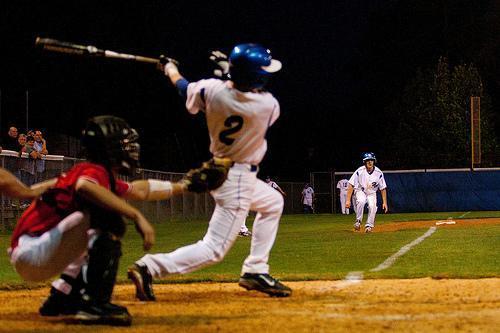How many boys are holding a bat?
Give a very brief answer. 1. 